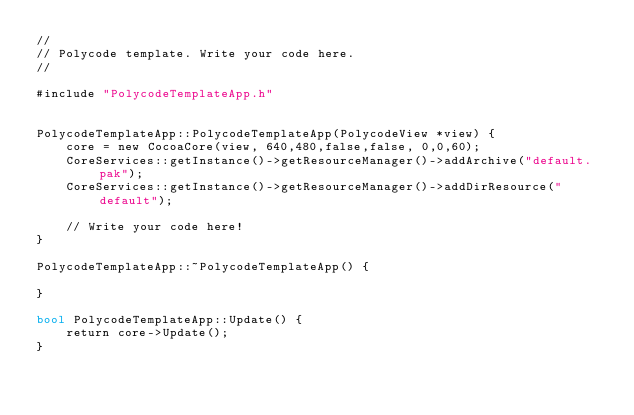Convert code to text. <code><loc_0><loc_0><loc_500><loc_500><_ObjectiveC_>//
// Polycode template. Write your code here.
// 

#include "PolycodeTemplateApp.h"


PolycodeTemplateApp::PolycodeTemplateApp(PolycodeView *view) {
    core = new CocoaCore(view, 640,480,false,false, 0,0,60);	  
	CoreServices::getInstance()->getResourceManager()->addArchive("default.pak");
	CoreServices::getInstance()->getResourceManager()->addDirResource("default");

	// Write your code here!
}

PolycodeTemplateApp::~PolycodeTemplateApp() {
    
}

bool PolycodeTemplateApp::Update() {
    return core->Update();
}</code> 